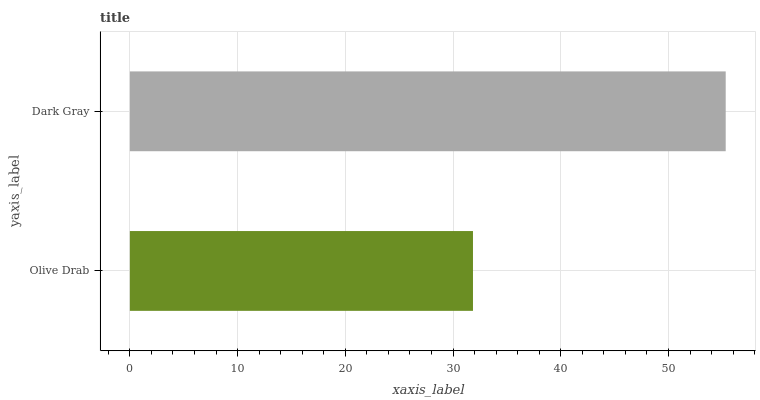Is Olive Drab the minimum?
Answer yes or no. Yes. Is Dark Gray the maximum?
Answer yes or no. Yes. Is Dark Gray the minimum?
Answer yes or no. No. Is Dark Gray greater than Olive Drab?
Answer yes or no. Yes. Is Olive Drab less than Dark Gray?
Answer yes or no. Yes. Is Olive Drab greater than Dark Gray?
Answer yes or no. No. Is Dark Gray less than Olive Drab?
Answer yes or no. No. Is Dark Gray the high median?
Answer yes or no. Yes. Is Olive Drab the low median?
Answer yes or no. Yes. Is Olive Drab the high median?
Answer yes or no. No. Is Dark Gray the low median?
Answer yes or no. No. 